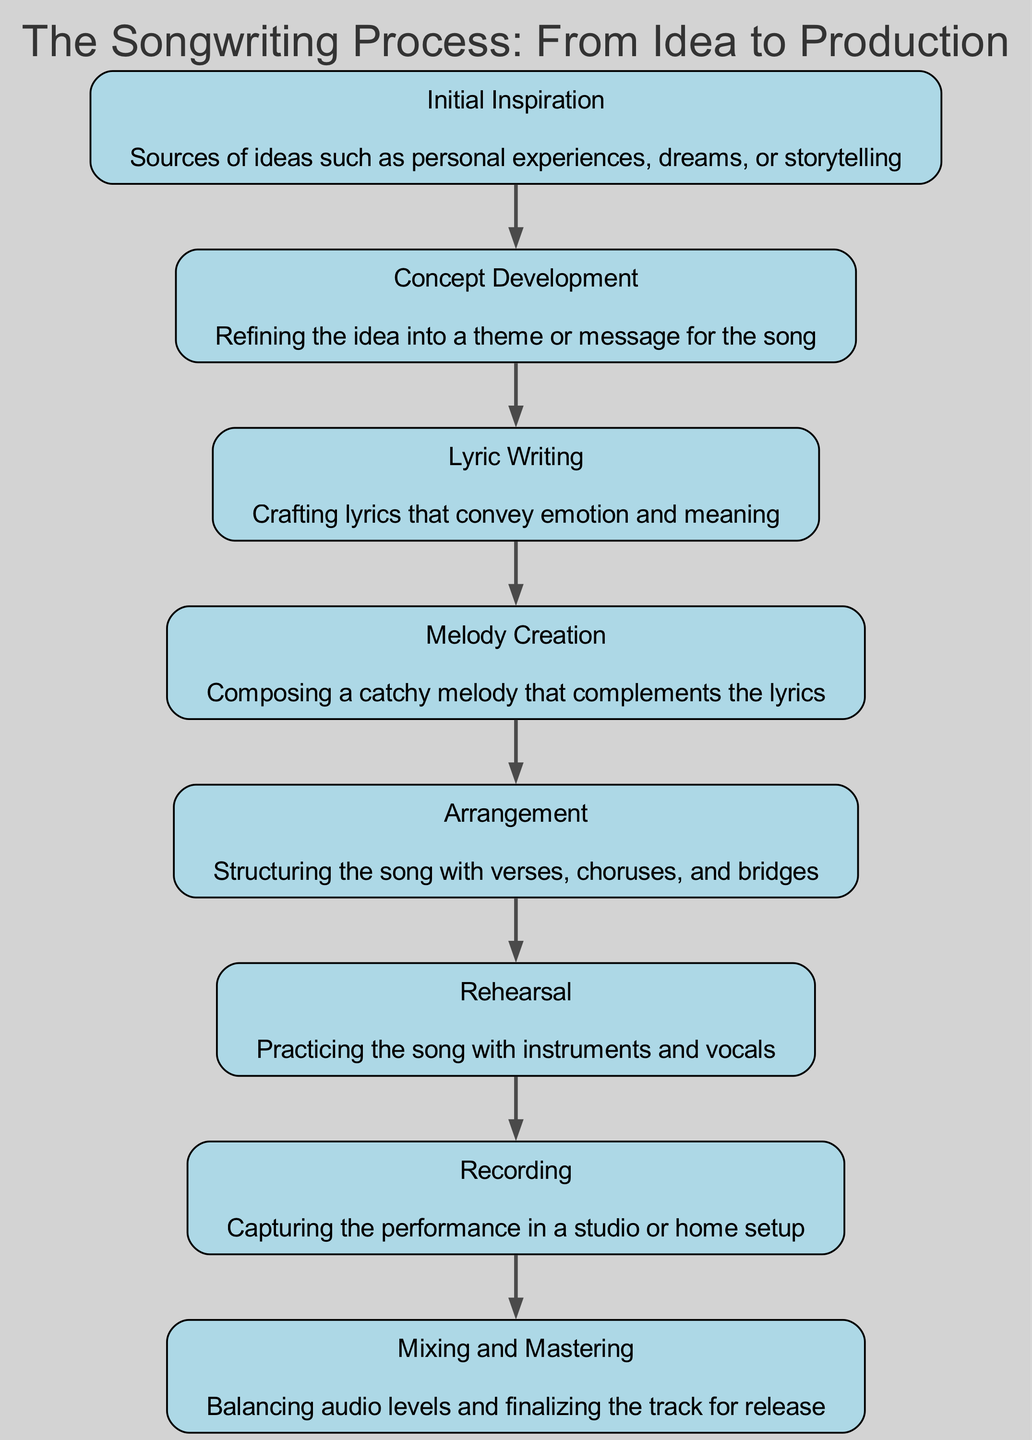What is the first stage of the songwriting process? The first stage listed in the diagram is "Initial Inspiration", which starts the flow of the songwriting process.
Answer: Initial Inspiration How many stages are there in the songwriting process? There are eight stages identified in the diagram, indicating the entire process from start to finish.
Answer: 8 What comes after lyric writing? Following "Lyric Writing", the next stage in the process is "Melody Creation", indicating the transition from words to musical composition.
Answer: Melody Creation What stage focuses on practicing the song? The stage that emphasizes practicing the song is labeled "Rehearsal", which comes before the recording phase.
Answer: Rehearsal Which stage involves capturing the performance? The stage that pertains to capturing the performance is "Recording", which is specifically described in the diagram.
Answer: Recording What is the relationship between arrangement and mixing? "Arrangement" comes before "Mixing and Mastering" in the flow, showing that structuring the song is a prerequisite to final audio adjustments.
Answer: Arrangement → Mixing and Mastering How many stages involve writing or composing? There are three stages that involve writing or composing: "Lyric Writing" and "Melody Creation", which pertain to both lyrics and melody composition.
Answer: 3 What is the last stage of the songwriting process? The last stage depicted in the diagram is "Mixing and Mastering", which finalizes the song for release.
Answer: Mixing and Mastering What is the main purpose of the concept development stage? The concept development stage is aimed at refining the initial idea into a theme or message for the song, making it clearer and more focused.
Answer: Refining the idea into a theme or message 